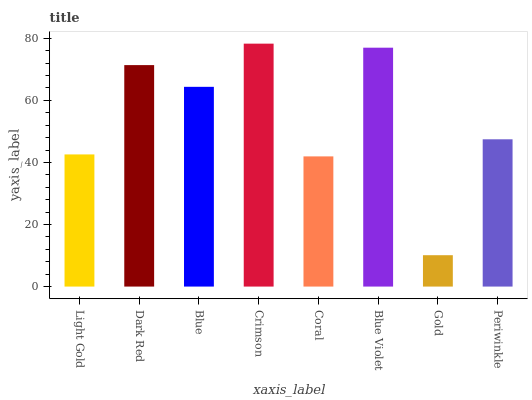Is Gold the minimum?
Answer yes or no. Yes. Is Crimson the maximum?
Answer yes or no. Yes. Is Dark Red the minimum?
Answer yes or no. No. Is Dark Red the maximum?
Answer yes or no. No. Is Dark Red greater than Light Gold?
Answer yes or no. Yes. Is Light Gold less than Dark Red?
Answer yes or no. Yes. Is Light Gold greater than Dark Red?
Answer yes or no. No. Is Dark Red less than Light Gold?
Answer yes or no. No. Is Blue the high median?
Answer yes or no. Yes. Is Periwinkle the low median?
Answer yes or no. Yes. Is Dark Red the high median?
Answer yes or no. No. Is Blue the low median?
Answer yes or no. No. 